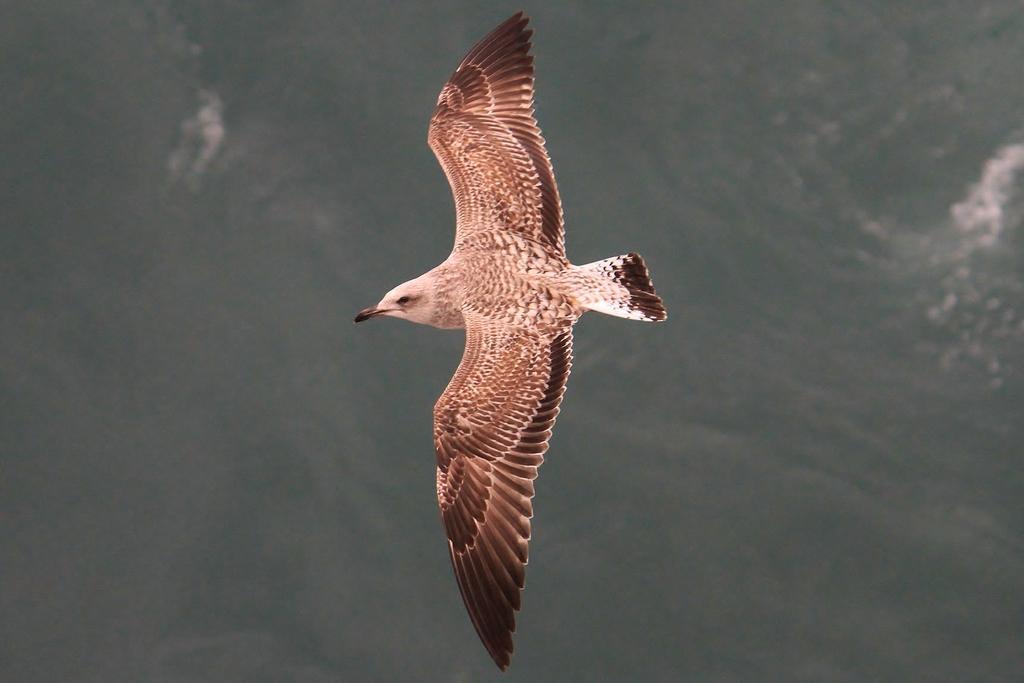Could you give a brief overview of what you see in this image? In this picture we can see a bird flying in the sky. 